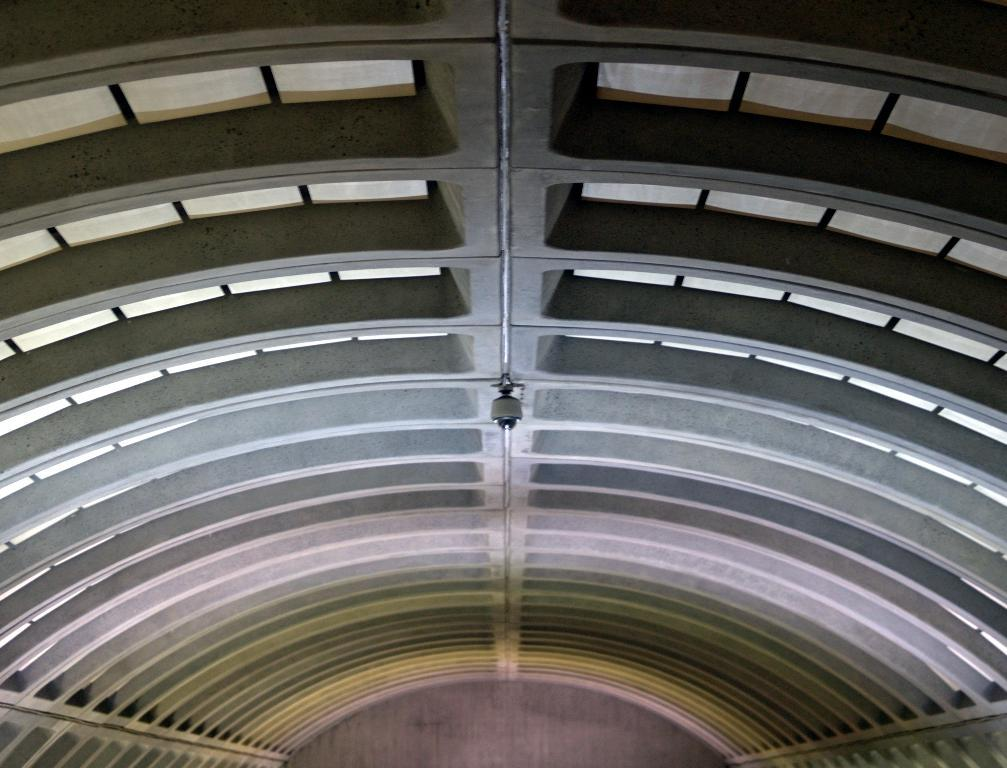What type of structure can be seen in the image? There is a building in the image. What else is present in the image besides the building? There is a pole in the image. What type of haircut does the frog have in the image? There is no frog present in the image, so it is not possible to determine the type of haircut it might have. 